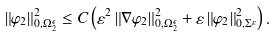Convert formula to latex. <formula><loc_0><loc_0><loc_500><loc_500>\left \| \varphi _ { 2 } \right \| _ { 0 , \Omega _ { 2 } ^ { \epsilon } } ^ { 2 } \leq C \left ( \varepsilon ^ { 2 } \left \| \nabla \varphi _ { 2 } \right \| _ { 0 , \Omega _ { 2 } ^ { \epsilon } } ^ { 2 } + \varepsilon \left \| \varphi _ { 2 } \right \| _ { 0 , \Sigma ^ { \varepsilon } } ^ { 2 } \right ) .</formula> 